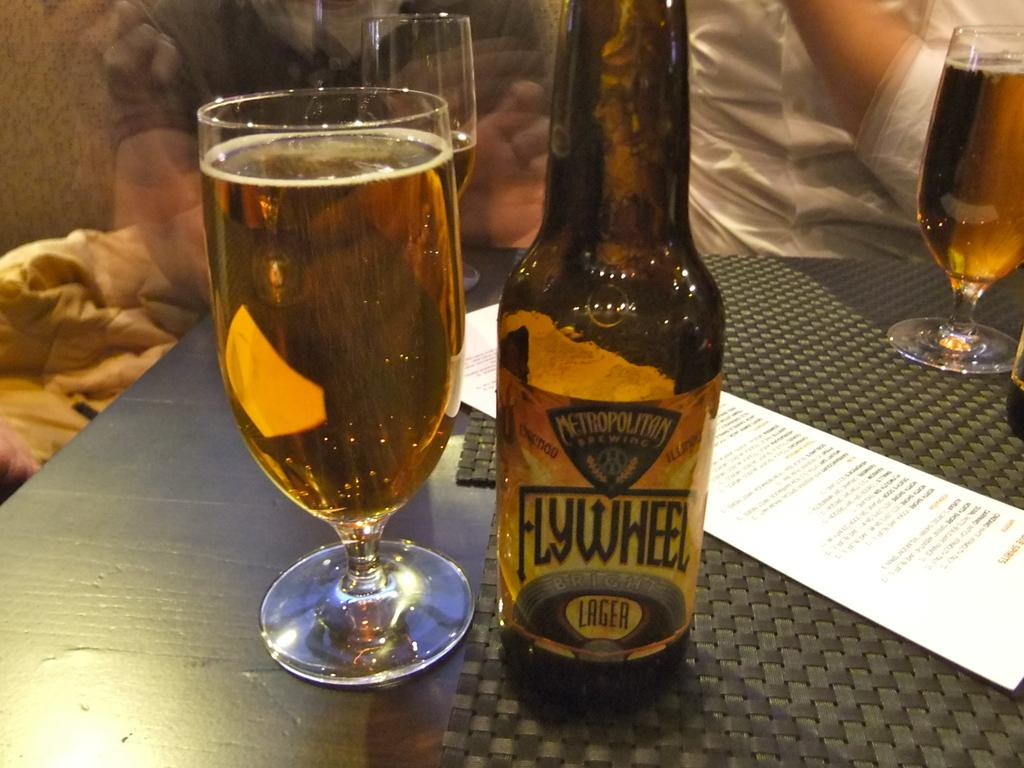<image>
Summarize the visual content of the image. A bootle of Flywheel lager is poured into a glass sitting next to it. 